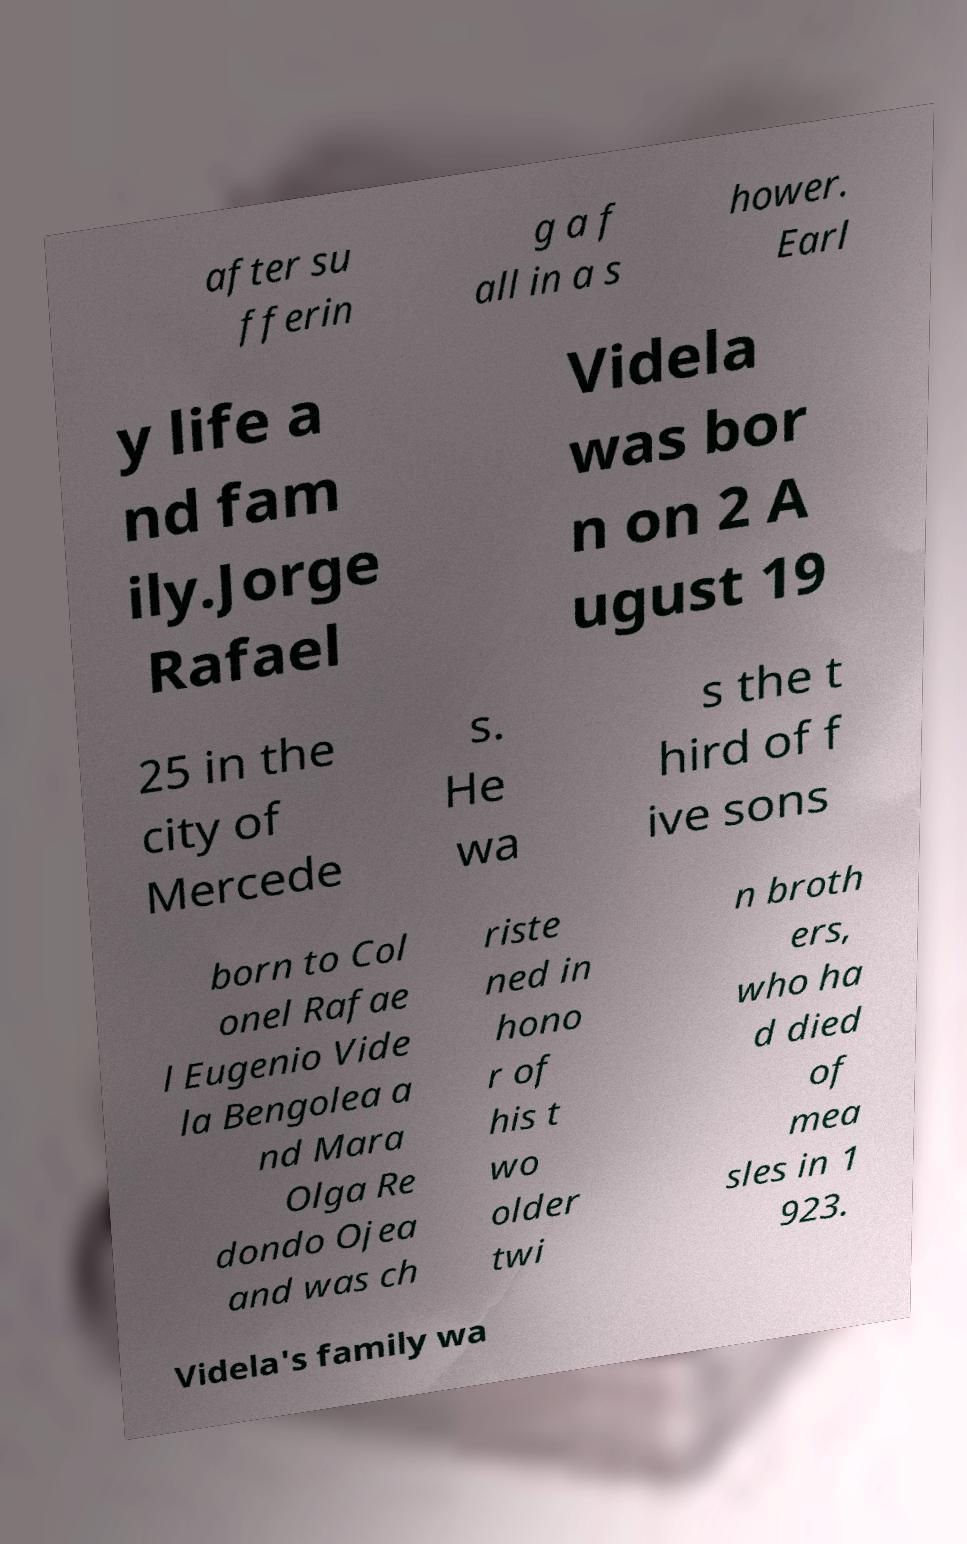Could you assist in decoding the text presented in this image and type it out clearly? after su fferin g a f all in a s hower. Earl y life a nd fam ily.Jorge Rafael Videla was bor n on 2 A ugust 19 25 in the city of Mercede s. He wa s the t hird of f ive sons born to Col onel Rafae l Eugenio Vide la Bengolea a nd Mara Olga Re dondo Ojea and was ch riste ned in hono r of his t wo older twi n broth ers, who ha d died of mea sles in 1 923. Videla's family wa 